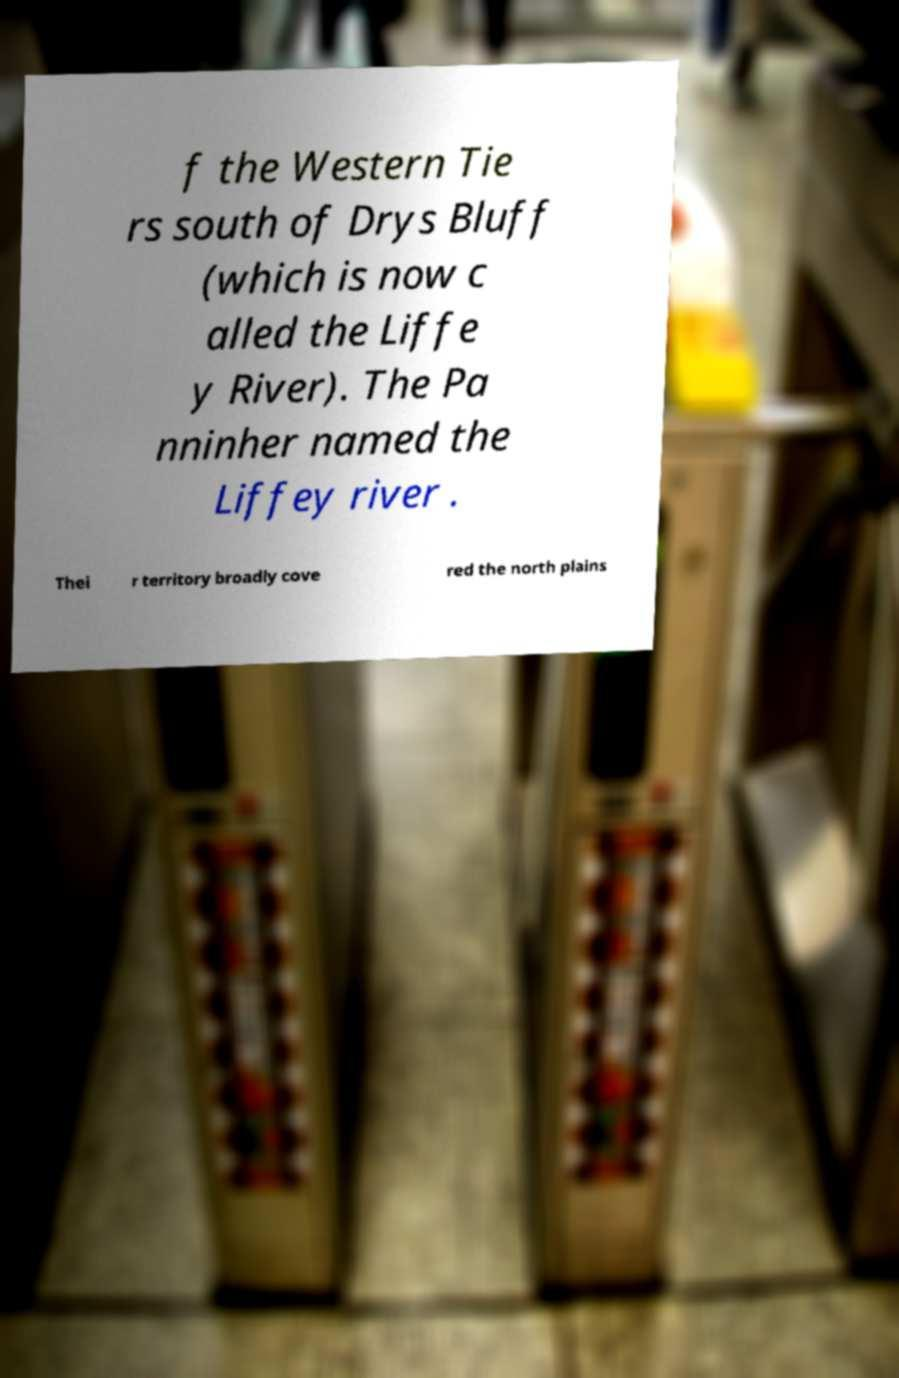Could you extract and type out the text from this image? f the Western Tie rs south of Drys Bluff (which is now c alled the Liffe y River). The Pa nninher named the Liffey river . Thei r territory broadly cove red the north plains 